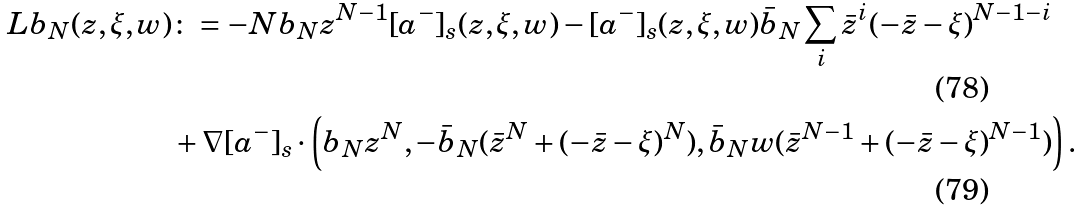<formula> <loc_0><loc_0><loc_500><loc_500>L b _ { N } ( z , \xi , w ) & \colon = - N b _ { N } z ^ { N - 1 } [ a ^ { - } ] _ { s } ( z , \xi , w ) - [ a ^ { - } ] _ { s } ( z , \xi , w ) \bar { b } _ { N } \sum _ { i } \bar { z } ^ { i } ( - \bar { z } - \xi ) ^ { N - 1 - i } \\ & + \nabla [ a ^ { - } ] _ { s } \cdot \left ( b _ { N } z ^ { N } , - \bar { b } _ { N } ( \bar { z } ^ { N } + ( - \bar { z } - \xi ) ^ { N } ) , \bar { b } _ { N } w ( \bar { z } ^ { N - 1 } + ( - \bar { z } - \xi ) ^ { N - 1 } ) \right ) .</formula> 